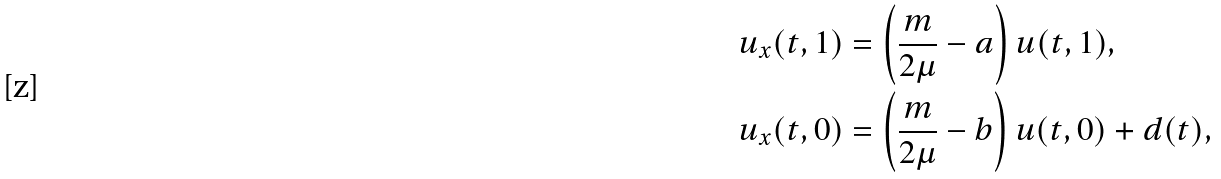Convert formula to latex. <formula><loc_0><loc_0><loc_500><loc_500>u _ { x } ( t , 1 ) & = \left ( \frac { m } { 2 \mu } - a \right ) u ( t , 1 ) , \\ u _ { x } ( t , 0 ) & = \left ( \frac { m } { 2 \mu } - b \right ) u ( t , 0 ) + d ( t ) ,</formula> 